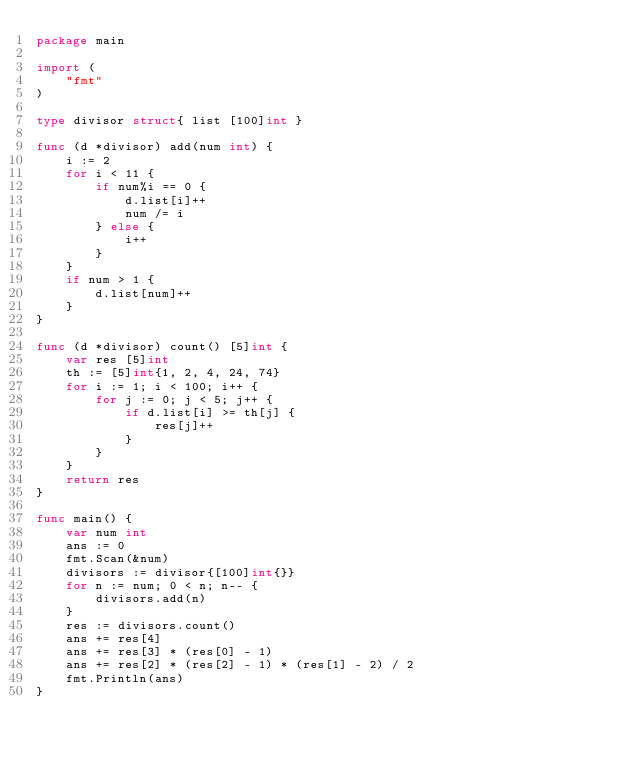Convert code to text. <code><loc_0><loc_0><loc_500><loc_500><_Go_>package main

import (
	"fmt"
)

type divisor struct{ list [100]int }

func (d *divisor) add(num int) {
	i := 2
	for i < 11 {
		if num%i == 0 {
			d.list[i]++
			num /= i
		} else {
			i++
		}
	}
	if num > 1 {
		d.list[num]++
	}
}

func (d *divisor) count() [5]int {
	var res [5]int
	th := [5]int{1, 2, 4, 24, 74}
	for i := 1; i < 100; i++ {
		for j := 0; j < 5; j++ {
			if d.list[i] >= th[j] {
				res[j]++
			}
		}
	}
	return res
}

func main() {
	var num int
	ans := 0
	fmt.Scan(&num)
	divisors := divisor{[100]int{}}
	for n := num; 0 < n; n-- {
		divisors.add(n)
	}
	res := divisors.count()
	ans += res[4]
	ans += res[3] * (res[0] - 1)
	ans += res[2] * (res[2] - 1) * (res[1] - 2) / 2
	fmt.Println(ans)
}</code> 